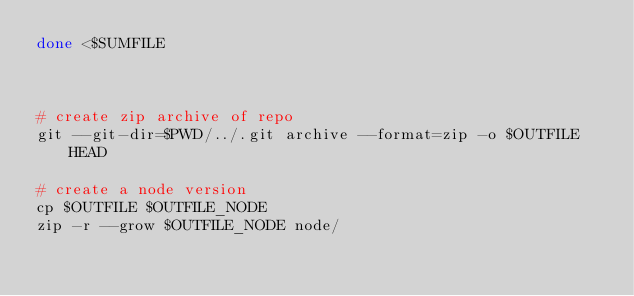Convert code to text. <code><loc_0><loc_0><loc_500><loc_500><_Bash_>done <$SUMFILE



# create zip archive of repo
git --git-dir=$PWD/../.git archive --format=zip -o $OUTFILE HEAD

# create a node version
cp $OUTFILE $OUTFILE_NODE
zip -r --grow $OUTFILE_NODE node/
</code> 